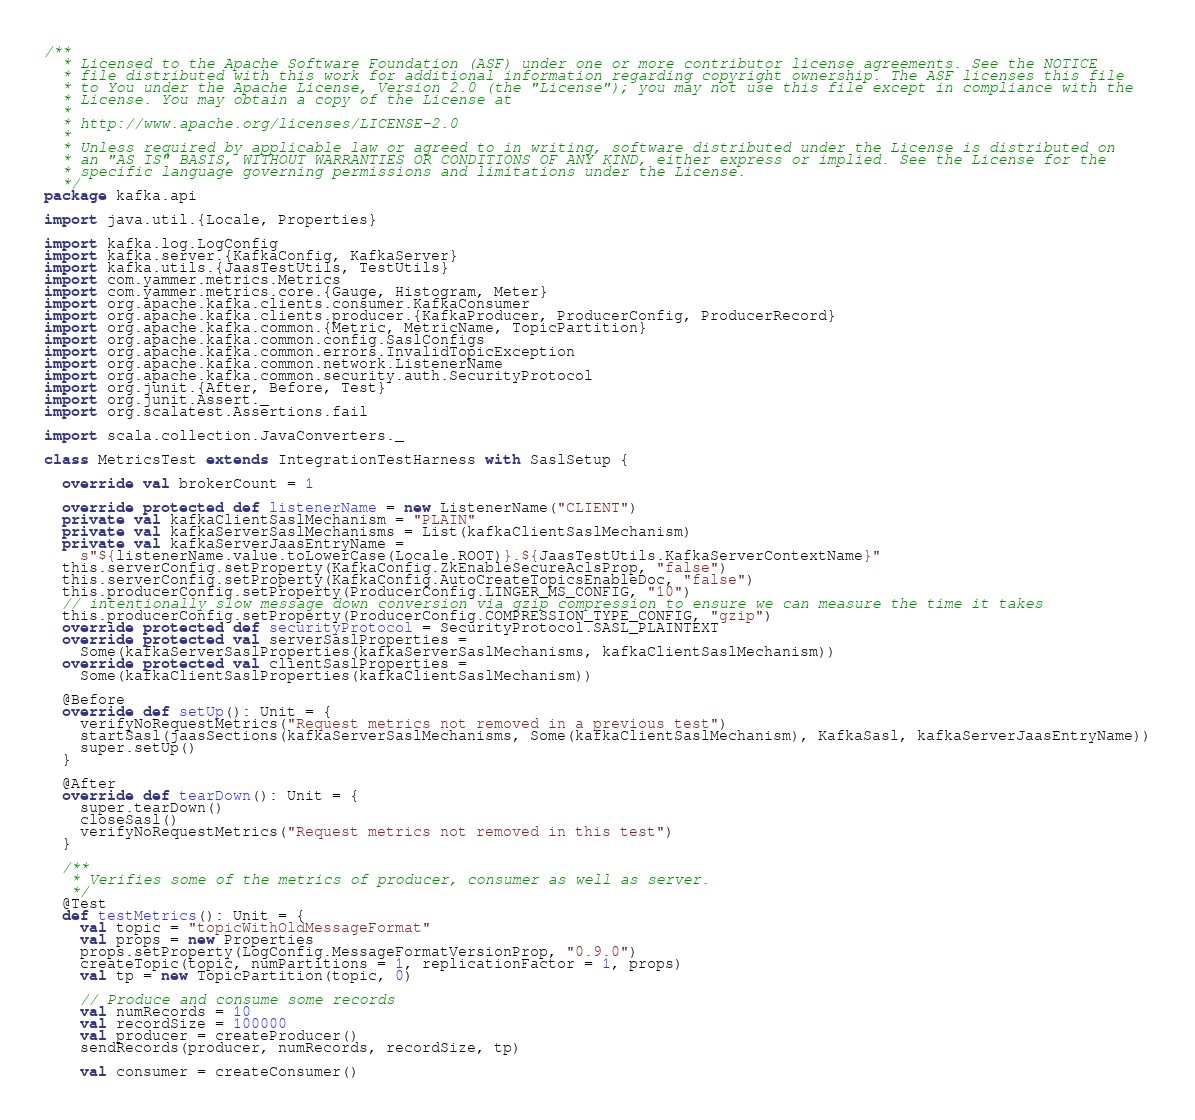Convert code to text. <code><loc_0><loc_0><loc_500><loc_500><_Scala_>/**
  * Licensed to the Apache Software Foundation (ASF) under one or more contributor license agreements. See the NOTICE
  * file distributed with this work for additional information regarding copyright ownership. The ASF licenses this file
  * to You under the Apache License, Version 2.0 (the "License"); you may not use this file except in compliance with the
  * License. You may obtain a copy of the License at
  *
  * http://www.apache.org/licenses/LICENSE-2.0
  *
  * Unless required by applicable law or agreed to in writing, software distributed under the License is distributed on
  * an "AS IS" BASIS, WITHOUT WARRANTIES OR CONDITIONS OF ANY KIND, either express or implied. See the License for the
  * specific language governing permissions and limitations under the License.
  */
package kafka.api

import java.util.{Locale, Properties}

import kafka.log.LogConfig
import kafka.server.{KafkaConfig, KafkaServer}
import kafka.utils.{JaasTestUtils, TestUtils}
import com.yammer.metrics.Metrics
import com.yammer.metrics.core.{Gauge, Histogram, Meter}
import org.apache.kafka.clients.consumer.KafkaConsumer
import org.apache.kafka.clients.producer.{KafkaProducer, ProducerConfig, ProducerRecord}
import org.apache.kafka.common.{Metric, MetricName, TopicPartition}
import org.apache.kafka.common.config.SaslConfigs
import org.apache.kafka.common.errors.InvalidTopicException
import org.apache.kafka.common.network.ListenerName
import org.apache.kafka.common.security.auth.SecurityProtocol
import org.junit.{After, Before, Test}
import org.junit.Assert._
import org.scalatest.Assertions.fail

import scala.collection.JavaConverters._

class MetricsTest extends IntegrationTestHarness with SaslSetup {

  override val brokerCount = 1

  override protected def listenerName = new ListenerName("CLIENT")
  private val kafkaClientSaslMechanism = "PLAIN"
  private val kafkaServerSaslMechanisms = List(kafkaClientSaslMechanism)
  private val kafkaServerJaasEntryName =
    s"${listenerName.value.toLowerCase(Locale.ROOT)}.${JaasTestUtils.KafkaServerContextName}"
  this.serverConfig.setProperty(KafkaConfig.ZkEnableSecureAclsProp, "false")
  this.serverConfig.setProperty(KafkaConfig.AutoCreateTopicsEnableDoc, "false")
  this.producerConfig.setProperty(ProducerConfig.LINGER_MS_CONFIG, "10")
  // intentionally slow message down conversion via gzip compression to ensure we can measure the time it takes
  this.producerConfig.setProperty(ProducerConfig.COMPRESSION_TYPE_CONFIG, "gzip")
  override protected def securityProtocol = SecurityProtocol.SASL_PLAINTEXT
  override protected val serverSaslProperties =
    Some(kafkaServerSaslProperties(kafkaServerSaslMechanisms, kafkaClientSaslMechanism))
  override protected val clientSaslProperties =
    Some(kafkaClientSaslProperties(kafkaClientSaslMechanism))

  @Before
  override def setUp(): Unit = {
    verifyNoRequestMetrics("Request metrics not removed in a previous test")
    startSasl(jaasSections(kafkaServerSaslMechanisms, Some(kafkaClientSaslMechanism), KafkaSasl, kafkaServerJaasEntryName))
    super.setUp()
  }

  @After
  override def tearDown(): Unit = {
    super.tearDown()
    closeSasl()
    verifyNoRequestMetrics("Request metrics not removed in this test")
  }

  /**
   * Verifies some of the metrics of producer, consumer as well as server.
   */
  @Test
  def testMetrics(): Unit = {
    val topic = "topicWithOldMessageFormat"
    val props = new Properties
    props.setProperty(LogConfig.MessageFormatVersionProp, "0.9.0")
    createTopic(topic, numPartitions = 1, replicationFactor = 1, props)
    val tp = new TopicPartition(topic, 0)

    // Produce and consume some records
    val numRecords = 10
    val recordSize = 100000
    val producer = createProducer()
    sendRecords(producer, numRecords, recordSize, tp)

    val consumer = createConsumer()</code> 